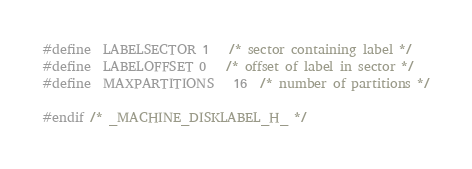<code> <loc_0><loc_0><loc_500><loc_500><_C_>
#define	LABELSECTOR	1	/* sector containing label */
#define	LABELOFFSET	0	/* offset of label in sector */
#define	MAXPARTITIONS	16	/* number of partitions */

#endif /* _MACHINE_DISKLABEL_H_ */
</code> 